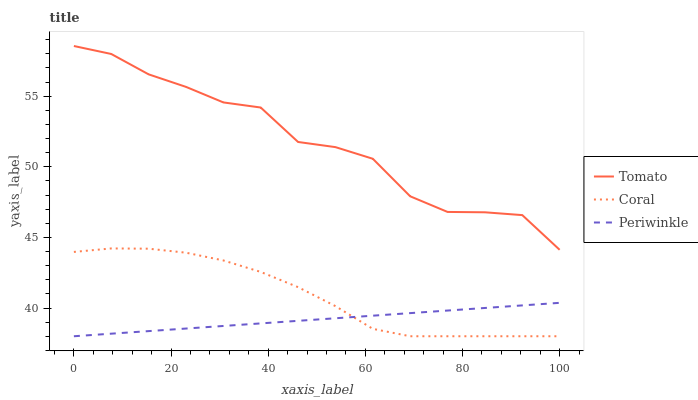Does Periwinkle have the minimum area under the curve?
Answer yes or no. Yes. Does Tomato have the maximum area under the curve?
Answer yes or no. Yes. Does Coral have the minimum area under the curve?
Answer yes or no. No. Does Coral have the maximum area under the curve?
Answer yes or no. No. Is Periwinkle the smoothest?
Answer yes or no. Yes. Is Tomato the roughest?
Answer yes or no. Yes. Is Coral the smoothest?
Answer yes or no. No. Is Coral the roughest?
Answer yes or no. No. Does Coral have the lowest value?
Answer yes or no. Yes. Does Tomato have the highest value?
Answer yes or no. Yes. Does Coral have the highest value?
Answer yes or no. No. Is Periwinkle less than Tomato?
Answer yes or no. Yes. Is Tomato greater than Periwinkle?
Answer yes or no. Yes. Does Coral intersect Periwinkle?
Answer yes or no. Yes. Is Coral less than Periwinkle?
Answer yes or no. No. Is Coral greater than Periwinkle?
Answer yes or no. No. Does Periwinkle intersect Tomato?
Answer yes or no. No. 